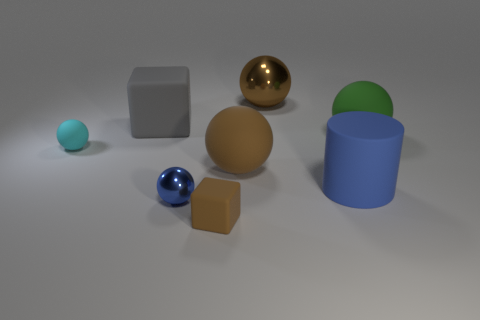Are there more tiny rubber blocks than big cyan rubber cylinders?
Ensure brevity in your answer.  Yes. The cylinder that is to the right of the large brown object behind the large green object behind the large blue rubber object is made of what material?
Your answer should be compact. Rubber. Does the big matte cylinder have the same color as the small metallic thing?
Offer a terse response. Yes. Are there any big shiny blocks that have the same color as the tiny shiny sphere?
Give a very brief answer. No. There is a brown rubber thing that is the same size as the blue cylinder; what shape is it?
Provide a short and direct response. Sphere. Are there fewer large blue rubber spheres than gray cubes?
Make the answer very short. Yes. What number of cylinders are the same size as the blue shiny ball?
Offer a terse response. 0. There is a object that is the same color as the small metal ball; what shape is it?
Offer a terse response. Cylinder. What is the material of the big gray block?
Your answer should be very brief. Rubber. There is a brown ball in front of the large gray matte cube; what is its size?
Offer a terse response. Large. 